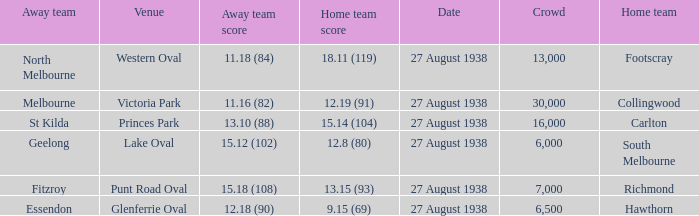Which Team plays at Western Oval? Footscray. 